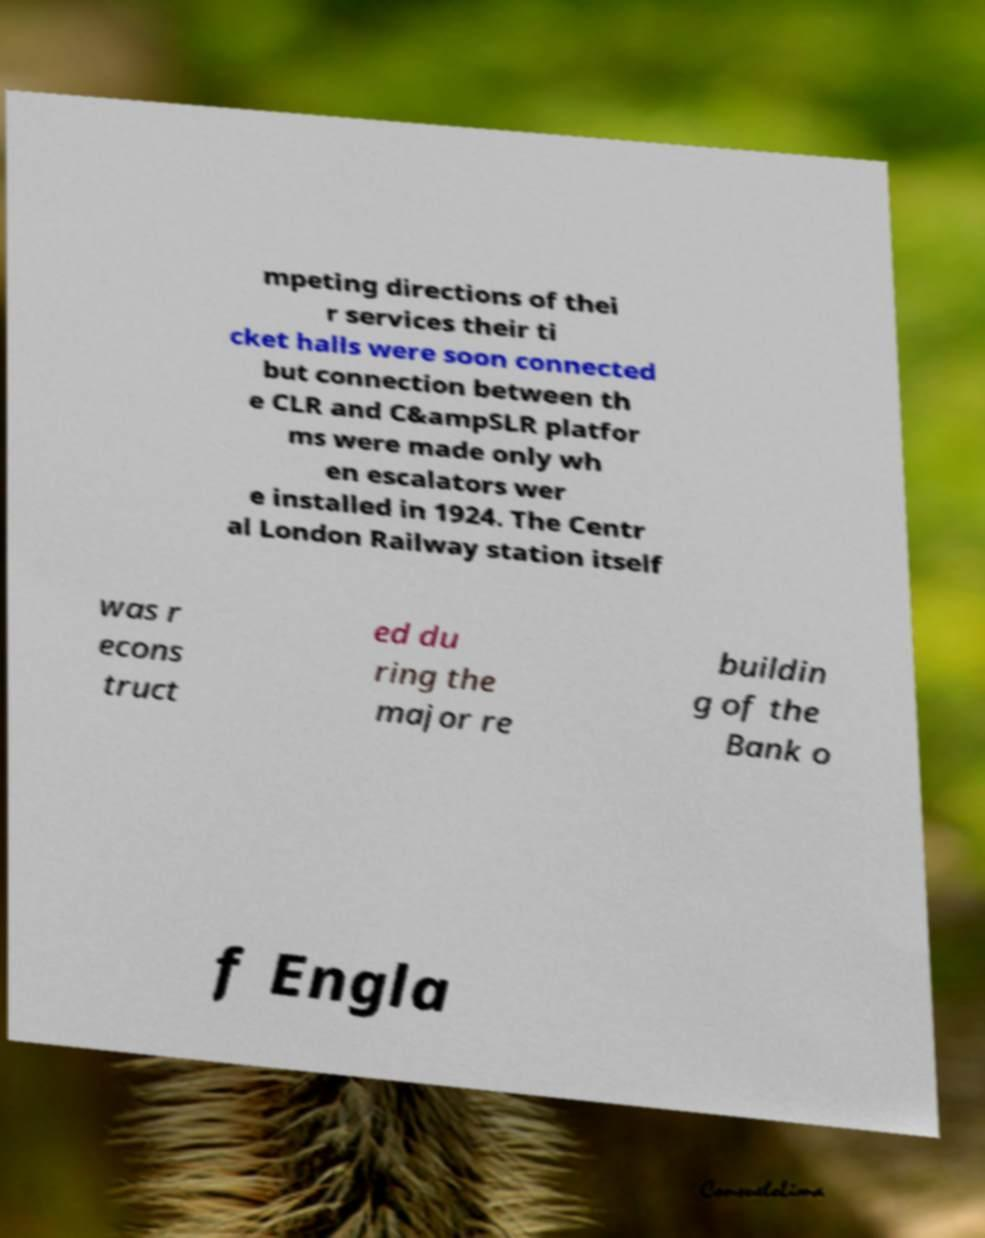Please read and relay the text visible in this image. What does it say? mpeting directions of thei r services their ti cket halls were soon connected but connection between th e CLR and C&ampSLR platfor ms were made only wh en escalators wer e installed in 1924. The Centr al London Railway station itself was r econs truct ed du ring the major re buildin g of the Bank o f Engla 